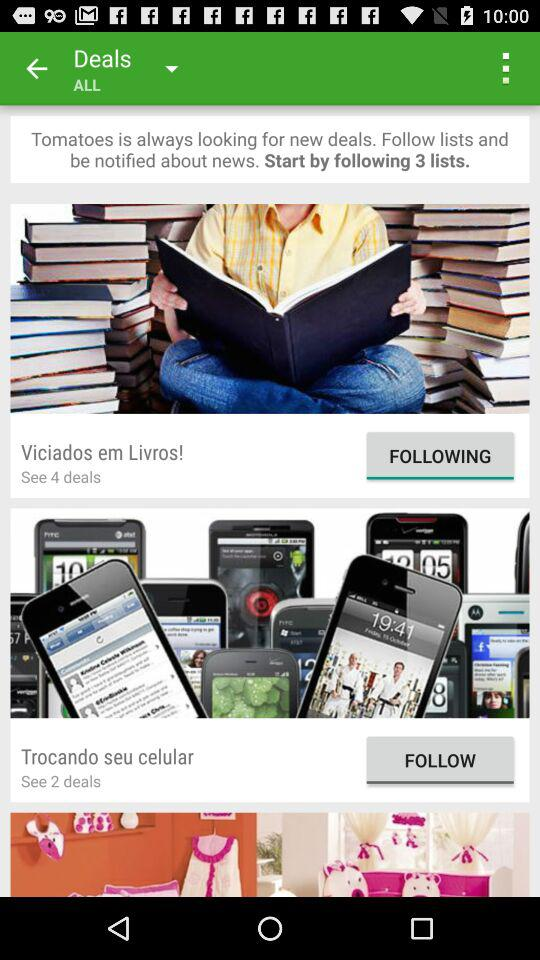Who is looking for new deals? Looking for new deals is done by "Tomatoes". 